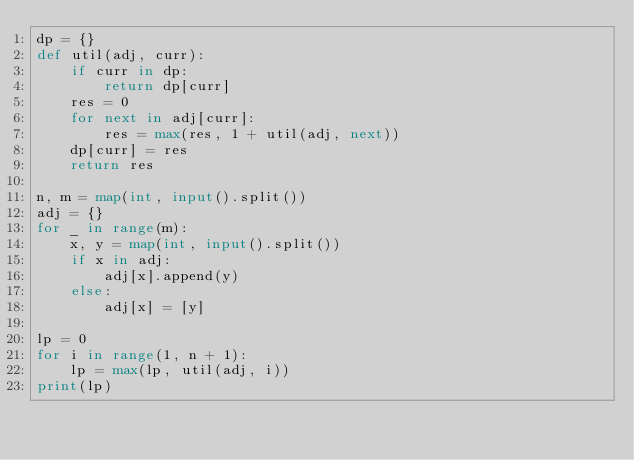Convert code to text. <code><loc_0><loc_0><loc_500><loc_500><_Python_>dp = {}
def util(adj, curr):
    if curr in dp:
        return dp[curr]
    res = 0
    for next in adj[curr]:
        res = max(res, 1 + util(adj, next))
    dp[curr] = res
    return res

n, m = map(int, input().split())
adj = {}
for _ in range(m):
    x, y = map(int, input().split())
    if x in adj:
        adj[x].append(y)
    else:
        adj[x] = [y]

lp = 0
for i in range(1, n + 1):
    lp = max(lp, util(adj, i))
print(lp)</code> 